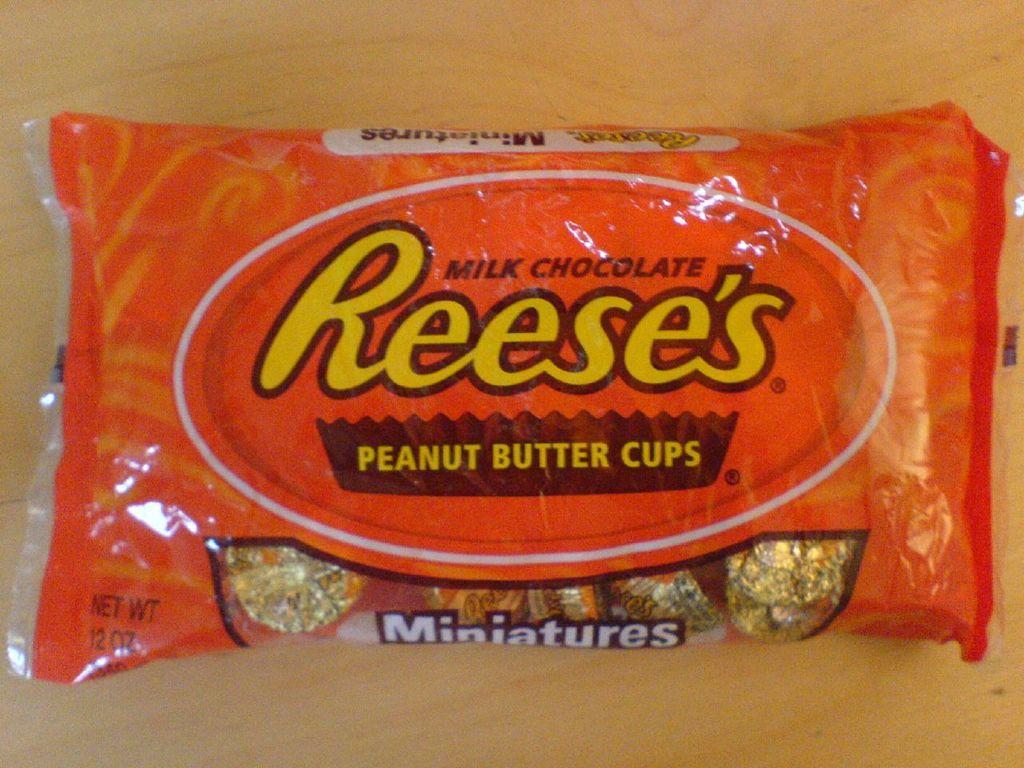How would you summarize this image in a sentence or two? In this image I can see food packet on the wooden surface. 